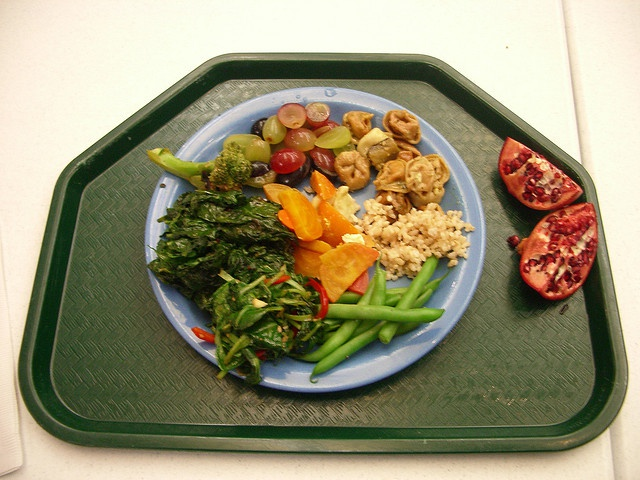Describe the objects in this image and their specific colors. I can see broccoli in tan, olive, black, and maroon tones, carrot in tan, orange, red, and brown tones, and carrot in tan, orange, red, and black tones in this image. 